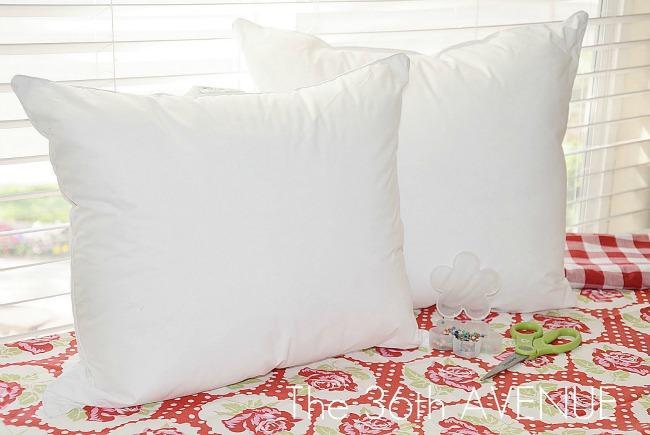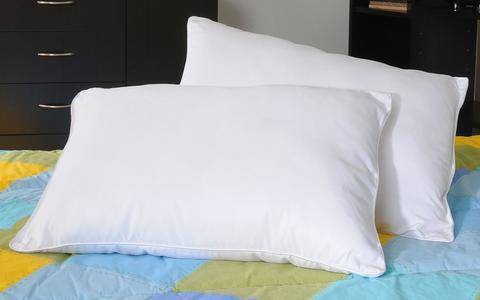The first image is the image on the left, the second image is the image on the right. Evaluate the accuracy of this statement regarding the images: "there is white bedding on a bed with dark curtains behind the bed". Is it true? Answer yes or no. No. The first image is the image on the left, the second image is the image on the right. Examine the images to the left and right. Is the description "One image shows a bed with all white bedding in front of a brown headboard and matching drape." accurate? Answer yes or no. No. 